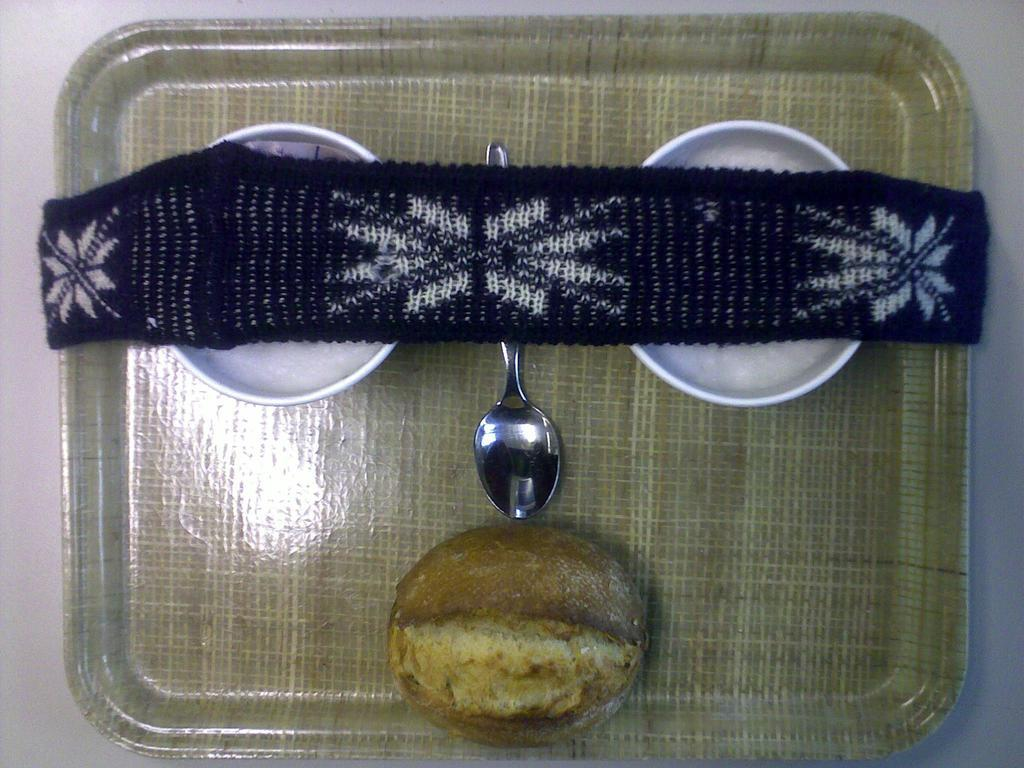What is the main subject of the image? There is a food item in the image. What utensil is present in the image? A spoon is visible in the image. What covers the bowls in the image? There is a cloth on the bowls in the image. How are the food items arranged in the image? The food items are on a tray. What color is the background of the image? The background of the image is white. What type of engine can be seen in the image? There is no engine present in the image. Is there a board game being played in the image? There is no board game or any indication of a game being played in the image. 